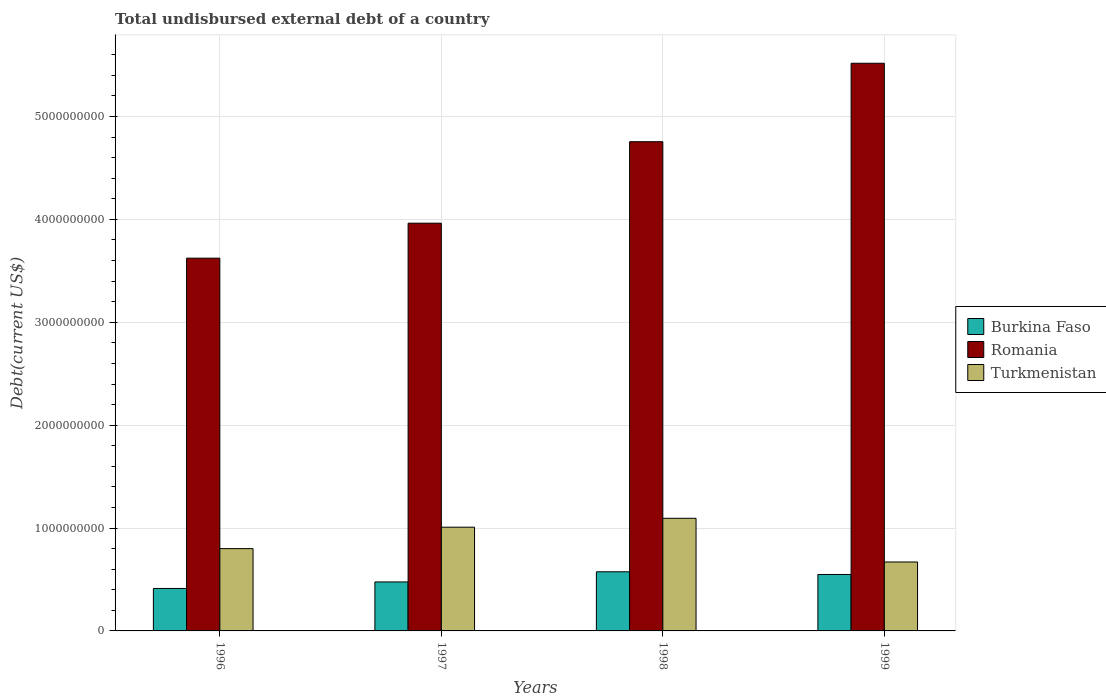How many different coloured bars are there?
Provide a short and direct response. 3. How many bars are there on the 4th tick from the right?
Offer a terse response. 3. What is the label of the 2nd group of bars from the left?
Your response must be concise. 1997. In how many cases, is the number of bars for a given year not equal to the number of legend labels?
Your answer should be compact. 0. What is the total undisbursed external debt in Burkina Faso in 1998?
Give a very brief answer. 5.75e+08. Across all years, what is the maximum total undisbursed external debt in Burkina Faso?
Offer a very short reply. 5.75e+08. Across all years, what is the minimum total undisbursed external debt in Romania?
Your response must be concise. 3.62e+09. In which year was the total undisbursed external debt in Turkmenistan minimum?
Provide a succinct answer. 1999. What is the total total undisbursed external debt in Turkmenistan in the graph?
Offer a very short reply. 3.57e+09. What is the difference between the total undisbursed external debt in Romania in 1996 and that in 1999?
Your response must be concise. -1.89e+09. What is the difference between the total undisbursed external debt in Romania in 1997 and the total undisbursed external debt in Burkina Faso in 1996?
Make the answer very short. 3.55e+09. What is the average total undisbursed external debt in Burkina Faso per year?
Your answer should be compact. 5.03e+08. In the year 1996, what is the difference between the total undisbursed external debt in Burkina Faso and total undisbursed external debt in Turkmenistan?
Ensure brevity in your answer.  -3.87e+08. In how many years, is the total undisbursed external debt in Turkmenistan greater than 1800000000 US$?
Ensure brevity in your answer.  0. What is the ratio of the total undisbursed external debt in Burkina Faso in 1996 to that in 1998?
Provide a short and direct response. 0.72. Is the difference between the total undisbursed external debt in Burkina Faso in 1996 and 1998 greater than the difference between the total undisbursed external debt in Turkmenistan in 1996 and 1998?
Make the answer very short. Yes. What is the difference between the highest and the second highest total undisbursed external debt in Romania?
Make the answer very short. 7.63e+08. What is the difference between the highest and the lowest total undisbursed external debt in Turkmenistan?
Offer a very short reply. 4.25e+08. In how many years, is the total undisbursed external debt in Burkina Faso greater than the average total undisbursed external debt in Burkina Faso taken over all years?
Give a very brief answer. 2. What does the 2nd bar from the left in 1999 represents?
Provide a short and direct response. Romania. What does the 1st bar from the right in 1999 represents?
Your answer should be compact. Turkmenistan. How many years are there in the graph?
Provide a succinct answer. 4. Are the values on the major ticks of Y-axis written in scientific E-notation?
Keep it short and to the point. No. Does the graph contain any zero values?
Your answer should be very brief. No. How many legend labels are there?
Provide a short and direct response. 3. What is the title of the graph?
Provide a short and direct response. Total undisbursed external debt of a country. What is the label or title of the Y-axis?
Make the answer very short. Debt(current US$). What is the Debt(current US$) in Burkina Faso in 1996?
Keep it short and to the point. 4.13e+08. What is the Debt(current US$) of Romania in 1996?
Your response must be concise. 3.62e+09. What is the Debt(current US$) in Turkmenistan in 1996?
Offer a very short reply. 8.00e+08. What is the Debt(current US$) of Burkina Faso in 1997?
Offer a terse response. 4.76e+08. What is the Debt(current US$) in Romania in 1997?
Your response must be concise. 3.96e+09. What is the Debt(current US$) of Turkmenistan in 1997?
Make the answer very short. 1.01e+09. What is the Debt(current US$) in Burkina Faso in 1998?
Ensure brevity in your answer.  5.75e+08. What is the Debt(current US$) in Romania in 1998?
Make the answer very short. 4.76e+09. What is the Debt(current US$) in Turkmenistan in 1998?
Your answer should be very brief. 1.09e+09. What is the Debt(current US$) of Burkina Faso in 1999?
Your answer should be very brief. 5.49e+08. What is the Debt(current US$) in Romania in 1999?
Provide a succinct answer. 5.52e+09. What is the Debt(current US$) of Turkmenistan in 1999?
Provide a short and direct response. 6.70e+08. Across all years, what is the maximum Debt(current US$) in Burkina Faso?
Your answer should be compact. 5.75e+08. Across all years, what is the maximum Debt(current US$) of Romania?
Make the answer very short. 5.52e+09. Across all years, what is the maximum Debt(current US$) of Turkmenistan?
Your response must be concise. 1.09e+09. Across all years, what is the minimum Debt(current US$) in Burkina Faso?
Ensure brevity in your answer.  4.13e+08. Across all years, what is the minimum Debt(current US$) of Romania?
Your answer should be compact. 3.62e+09. Across all years, what is the minimum Debt(current US$) of Turkmenistan?
Provide a short and direct response. 6.70e+08. What is the total Debt(current US$) of Burkina Faso in the graph?
Ensure brevity in your answer.  2.01e+09. What is the total Debt(current US$) of Romania in the graph?
Make the answer very short. 1.79e+1. What is the total Debt(current US$) of Turkmenistan in the graph?
Offer a terse response. 3.57e+09. What is the difference between the Debt(current US$) of Burkina Faso in 1996 and that in 1997?
Your answer should be compact. -6.34e+07. What is the difference between the Debt(current US$) of Romania in 1996 and that in 1997?
Offer a very short reply. -3.40e+08. What is the difference between the Debt(current US$) of Turkmenistan in 1996 and that in 1997?
Offer a terse response. -2.08e+08. What is the difference between the Debt(current US$) in Burkina Faso in 1996 and that in 1998?
Your answer should be compact. -1.62e+08. What is the difference between the Debt(current US$) in Romania in 1996 and that in 1998?
Your answer should be compact. -1.13e+09. What is the difference between the Debt(current US$) in Turkmenistan in 1996 and that in 1998?
Make the answer very short. -2.95e+08. What is the difference between the Debt(current US$) of Burkina Faso in 1996 and that in 1999?
Give a very brief answer. -1.36e+08. What is the difference between the Debt(current US$) in Romania in 1996 and that in 1999?
Offer a very short reply. -1.89e+09. What is the difference between the Debt(current US$) in Turkmenistan in 1996 and that in 1999?
Your response must be concise. 1.30e+08. What is the difference between the Debt(current US$) in Burkina Faso in 1997 and that in 1998?
Give a very brief answer. -9.86e+07. What is the difference between the Debt(current US$) in Romania in 1997 and that in 1998?
Your response must be concise. -7.92e+08. What is the difference between the Debt(current US$) in Turkmenistan in 1997 and that in 1998?
Offer a terse response. -8.66e+07. What is the difference between the Debt(current US$) in Burkina Faso in 1997 and that in 1999?
Provide a succinct answer. -7.25e+07. What is the difference between the Debt(current US$) of Romania in 1997 and that in 1999?
Provide a short and direct response. -1.55e+09. What is the difference between the Debt(current US$) in Turkmenistan in 1997 and that in 1999?
Provide a succinct answer. 3.38e+08. What is the difference between the Debt(current US$) in Burkina Faso in 1998 and that in 1999?
Make the answer very short. 2.60e+07. What is the difference between the Debt(current US$) in Romania in 1998 and that in 1999?
Offer a terse response. -7.63e+08. What is the difference between the Debt(current US$) in Turkmenistan in 1998 and that in 1999?
Your answer should be compact. 4.25e+08. What is the difference between the Debt(current US$) in Burkina Faso in 1996 and the Debt(current US$) in Romania in 1997?
Keep it short and to the point. -3.55e+09. What is the difference between the Debt(current US$) in Burkina Faso in 1996 and the Debt(current US$) in Turkmenistan in 1997?
Keep it short and to the point. -5.96e+08. What is the difference between the Debt(current US$) in Romania in 1996 and the Debt(current US$) in Turkmenistan in 1997?
Give a very brief answer. 2.62e+09. What is the difference between the Debt(current US$) in Burkina Faso in 1996 and the Debt(current US$) in Romania in 1998?
Your answer should be very brief. -4.34e+09. What is the difference between the Debt(current US$) in Burkina Faso in 1996 and the Debt(current US$) in Turkmenistan in 1998?
Offer a terse response. -6.82e+08. What is the difference between the Debt(current US$) in Romania in 1996 and the Debt(current US$) in Turkmenistan in 1998?
Give a very brief answer. 2.53e+09. What is the difference between the Debt(current US$) in Burkina Faso in 1996 and the Debt(current US$) in Romania in 1999?
Make the answer very short. -5.11e+09. What is the difference between the Debt(current US$) in Burkina Faso in 1996 and the Debt(current US$) in Turkmenistan in 1999?
Offer a very short reply. -2.57e+08. What is the difference between the Debt(current US$) in Romania in 1996 and the Debt(current US$) in Turkmenistan in 1999?
Make the answer very short. 2.95e+09. What is the difference between the Debt(current US$) in Burkina Faso in 1997 and the Debt(current US$) in Romania in 1998?
Offer a very short reply. -4.28e+09. What is the difference between the Debt(current US$) of Burkina Faso in 1997 and the Debt(current US$) of Turkmenistan in 1998?
Your answer should be compact. -6.19e+08. What is the difference between the Debt(current US$) in Romania in 1997 and the Debt(current US$) in Turkmenistan in 1998?
Make the answer very short. 2.87e+09. What is the difference between the Debt(current US$) of Burkina Faso in 1997 and the Debt(current US$) of Romania in 1999?
Provide a short and direct response. -5.04e+09. What is the difference between the Debt(current US$) in Burkina Faso in 1997 and the Debt(current US$) in Turkmenistan in 1999?
Make the answer very short. -1.94e+08. What is the difference between the Debt(current US$) in Romania in 1997 and the Debt(current US$) in Turkmenistan in 1999?
Your answer should be compact. 3.29e+09. What is the difference between the Debt(current US$) of Burkina Faso in 1998 and the Debt(current US$) of Romania in 1999?
Ensure brevity in your answer.  -4.94e+09. What is the difference between the Debt(current US$) of Burkina Faso in 1998 and the Debt(current US$) of Turkmenistan in 1999?
Your answer should be very brief. -9.52e+07. What is the difference between the Debt(current US$) in Romania in 1998 and the Debt(current US$) in Turkmenistan in 1999?
Keep it short and to the point. 4.09e+09. What is the average Debt(current US$) in Burkina Faso per year?
Give a very brief answer. 5.03e+08. What is the average Debt(current US$) of Romania per year?
Offer a terse response. 4.46e+09. What is the average Debt(current US$) in Turkmenistan per year?
Your answer should be compact. 8.93e+08. In the year 1996, what is the difference between the Debt(current US$) of Burkina Faso and Debt(current US$) of Romania?
Your answer should be compact. -3.21e+09. In the year 1996, what is the difference between the Debt(current US$) of Burkina Faso and Debt(current US$) of Turkmenistan?
Give a very brief answer. -3.87e+08. In the year 1996, what is the difference between the Debt(current US$) in Romania and Debt(current US$) in Turkmenistan?
Provide a short and direct response. 2.82e+09. In the year 1997, what is the difference between the Debt(current US$) in Burkina Faso and Debt(current US$) in Romania?
Make the answer very short. -3.49e+09. In the year 1997, what is the difference between the Debt(current US$) of Burkina Faso and Debt(current US$) of Turkmenistan?
Your response must be concise. -5.32e+08. In the year 1997, what is the difference between the Debt(current US$) in Romania and Debt(current US$) in Turkmenistan?
Offer a terse response. 2.96e+09. In the year 1998, what is the difference between the Debt(current US$) of Burkina Faso and Debt(current US$) of Romania?
Ensure brevity in your answer.  -4.18e+09. In the year 1998, what is the difference between the Debt(current US$) of Burkina Faso and Debt(current US$) of Turkmenistan?
Your answer should be very brief. -5.20e+08. In the year 1998, what is the difference between the Debt(current US$) in Romania and Debt(current US$) in Turkmenistan?
Make the answer very short. 3.66e+09. In the year 1999, what is the difference between the Debt(current US$) in Burkina Faso and Debt(current US$) in Romania?
Ensure brevity in your answer.  -4.97e+09. In the year 1999, what is the difference between the Debt(current US$) of Burkina Faso and Debt(current US$) of Turkmenistan?
Offer a very short reply. -1.21e+08. In the year 1999, what is the difference between the Debt(current US$) in Romania and Debt(current US$) in Turkmenistan?
Your answer should be compact. 4.85e+09. What is the ratio of the Debt(current US$) of Burkina Faso in 1996 to that in 1997?
Give a very brief answer. 0.87. What is the ratio of the Debt(current US$) of Romania in 1996 to that in 1997?
Provide a succinct answer. 0.91. What is the ratio of the Debt(current US$) of Turkmenistan in 1996 to that in 1997?
Offer a very short reply. 0.79. What is the ratio of the Debt(current US$) in Burkina Faso in 1996 to that in 1998?
Your answer should be compact. 0.72. What is the ratio of the Debt(current US$) of Romania in 1996 to that in 1998?
Offer a terse response. 0.76. What is the ratio of the Debt(current US$) of Turkmenistan in 1996 to that in 1998?
Provide a succinct answer. 0.73. What is the ratio of the Debt(current US$) in Burkina Faso in 1996 to that in 1999?
Provide a succinct answer. 0.75. What is the ratio of the Debt(current US$) of Romania in 1996 to that in 1999?
Offer a very short reply. 0.66. What is the ratio of the Debt(current US$) in Turkmenistan in 1996 to that in 1999?
Offer a very short reply. 1.19. What is the ratio of the Debt(current US$) in Burkina Faso in 1997 to that in 1998?
Provide a short and direct response. 0.83. What is the ratio of the Debt(current US$) of Romania in 1997 to that in 1998?
Offer a very short reply. 0.83. What is the ratio of the Debt(current US$) of Turkmenistan in 1997 to that in 1998?
Make the answer very short. 0.92. What is the ratio of the Debt(current US$) in Burkina Faso in 1997 to that in 1999?
Your answer should be very brief. 0.87. What is the ratio of the Debt(current US$) of Romania in 1997 to that in 1999?
Give a very brief answer. 0.72. What is the ratio of the Debt(current US$) in Turkmenistan in 1997 to that in 1999?
Ensure brevity in your answer.  1.5. What is the ratio of the Debt(current US$) of Burkina Faso in 1998 to that in 1999?
Your answer should be very brief. 1.05. What is the ratio of the Debt(current US$) in Romania in 1998 to that in 1999?
Offer a terse response. 0.86. What is the ratio of the Debt(current US$) in Turkmenistan in 1998 to that in 1999?
Provide a short and direct response. 1.63. What is the difference between the highest and the second highest Debt(current US$) of Burkina Faso?
Ensure brevity in your answer.  2.60e+07. What is the difference between the highest and the second highest Debt(current US$) of Romania?
Your answer should be compact. 7.63e+08. What is the difference between the highest and the second highest Debt(current US$) in Turkmenistan?
Your answer should be very brief. 8.66e+07. What is the difference between the highest and the lowest Debt(current US$) of Burkina Faso?
Provide a succinct answer. 1.62e+08. What is the difference between the highest and the lowest Debt(current US$) of Romania?
Provide a short and direct response. 1.89e+09. What is the difference between the highest and the lowest Debt(current US$) in Turkmenistan?
Offer a very short reply. 4.25e+08. 